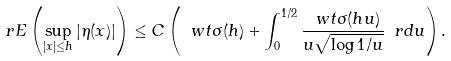Convert formula to latex. <formula><loc_0><loc_0><loc_500><loc_500>\ r E \left ( \sup _ { | x | \leq h } | \eta ( x ) | \right ) \leq C \left ( \ w t \sigma ( h ) + \int _ { 0 } ^ { 1 / 2 } \frac { \ w t \sigma ( h u ) } { u \sqrt { \log 1 / u } } \ r d u \right ) .</formula> 